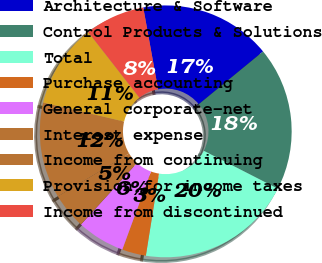<chart> <loc_0><loc_0><loc_500><loc_500><pie_chart><fcel>Architecture & Software<fcel>Control Products & Solutions<fcel>Total<fcel>Purchase accounting<fcel>General corporate-net<fcel>Interest expense<fcel>Income from continuing<fcel>Provision for income taxes<fcel>Income from discontinued<nl><fcel>16.92%<fcel>18.46%<fcel>20.0%<fcel>3.08%<fcel>6.15%<fcel>4.62%<fcel>12.31%<fcel>10.77%<fcel>7.69%<nl></chart> 